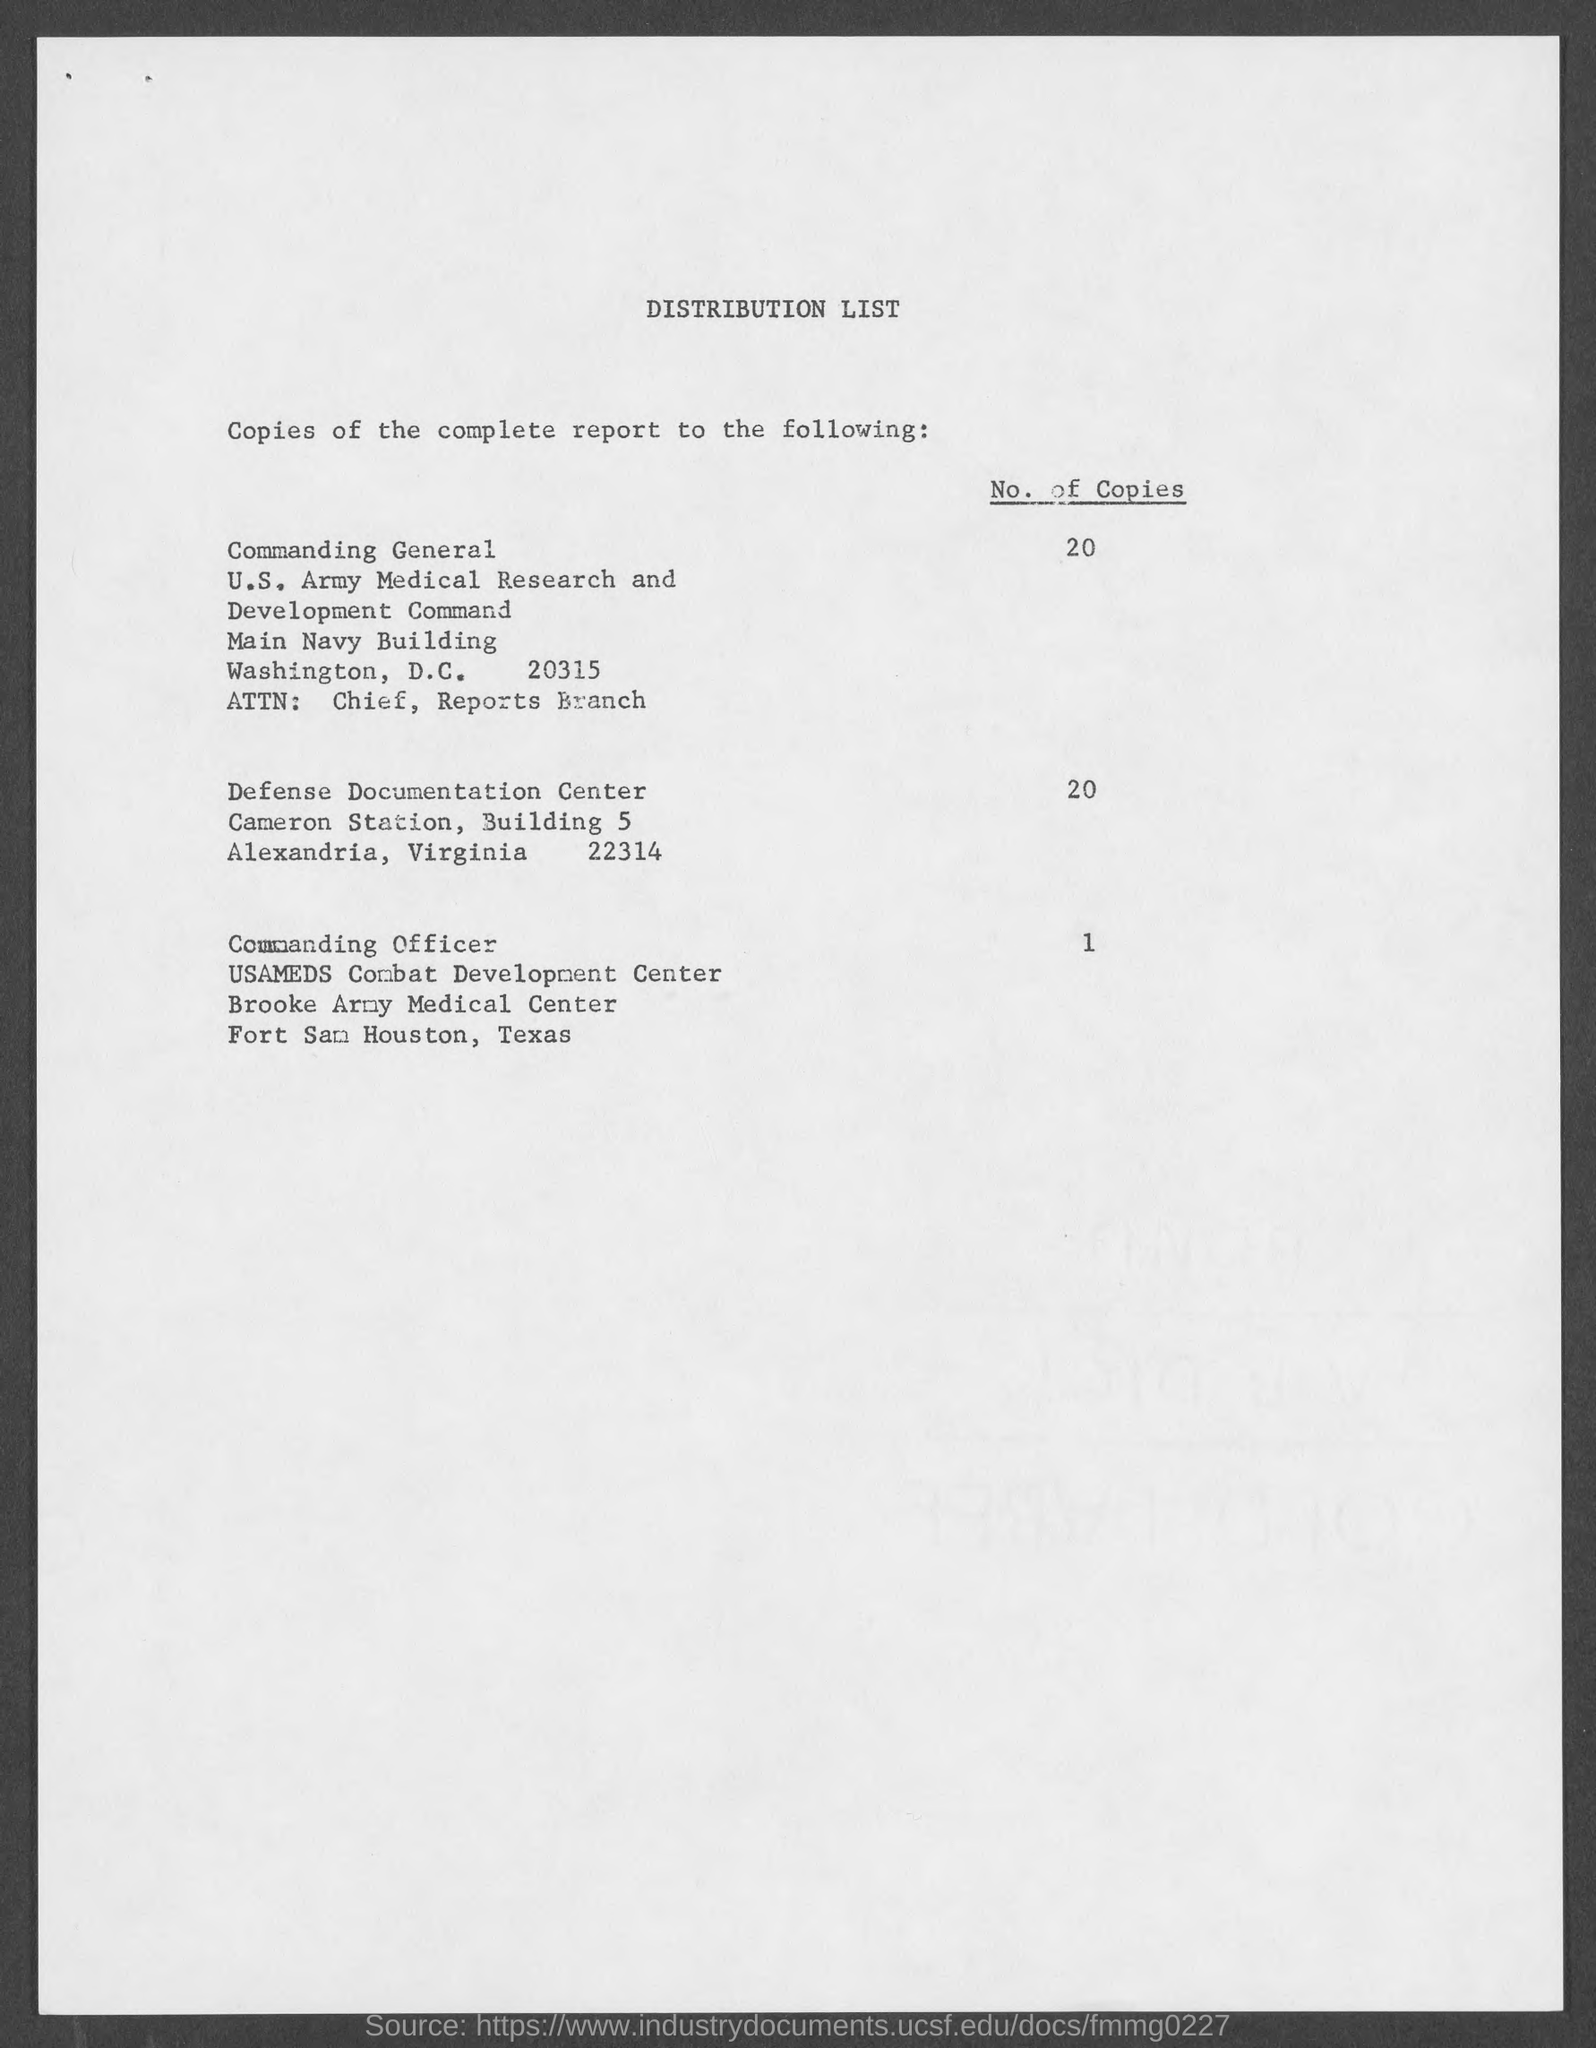List a handful of essential elements in this visual. The number of copies for the commanding officer is one. The title of the document is "Distribution List. The number of copies for the Defense Documentation Center is 20. The Commanding General is located in the main Navy building. The station where Defense Documentation is located is... 